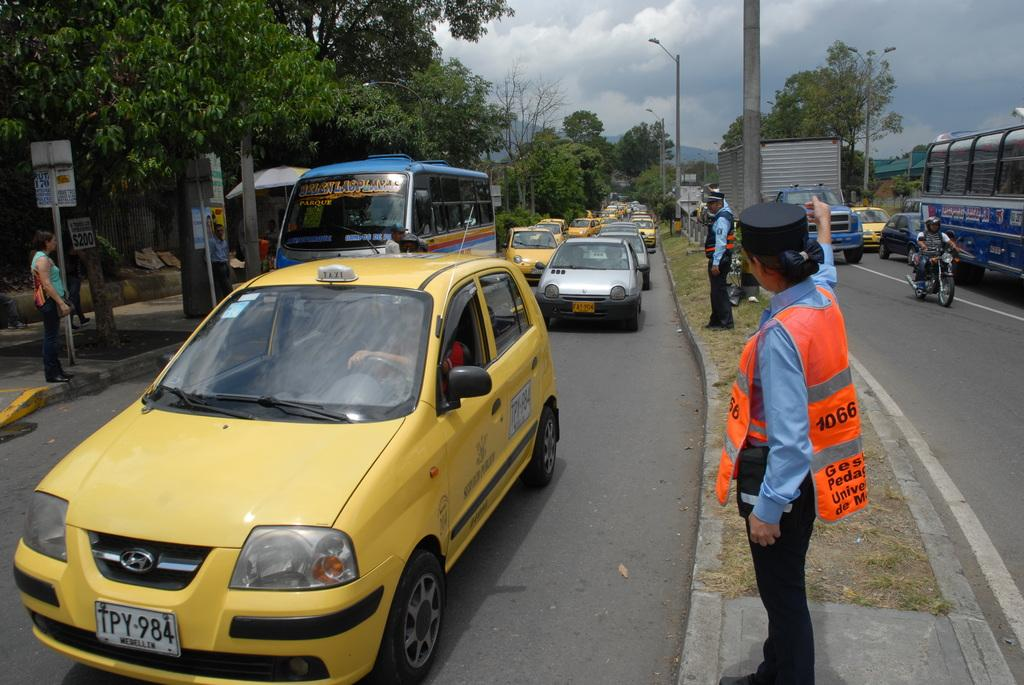<image>
Provide a brief description of the given image. The yellow car shown at the front is a taxi. 